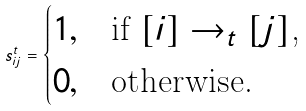<formula> <loc_0><loc_0><loc_500><loc_500>s _ { i j } ^ { t } = \begin{cases} 1 , & \text {if $[i]\to_{t}[j]$,} \\ 0 , & \text {otherwise.} \end{cases}</formula> 